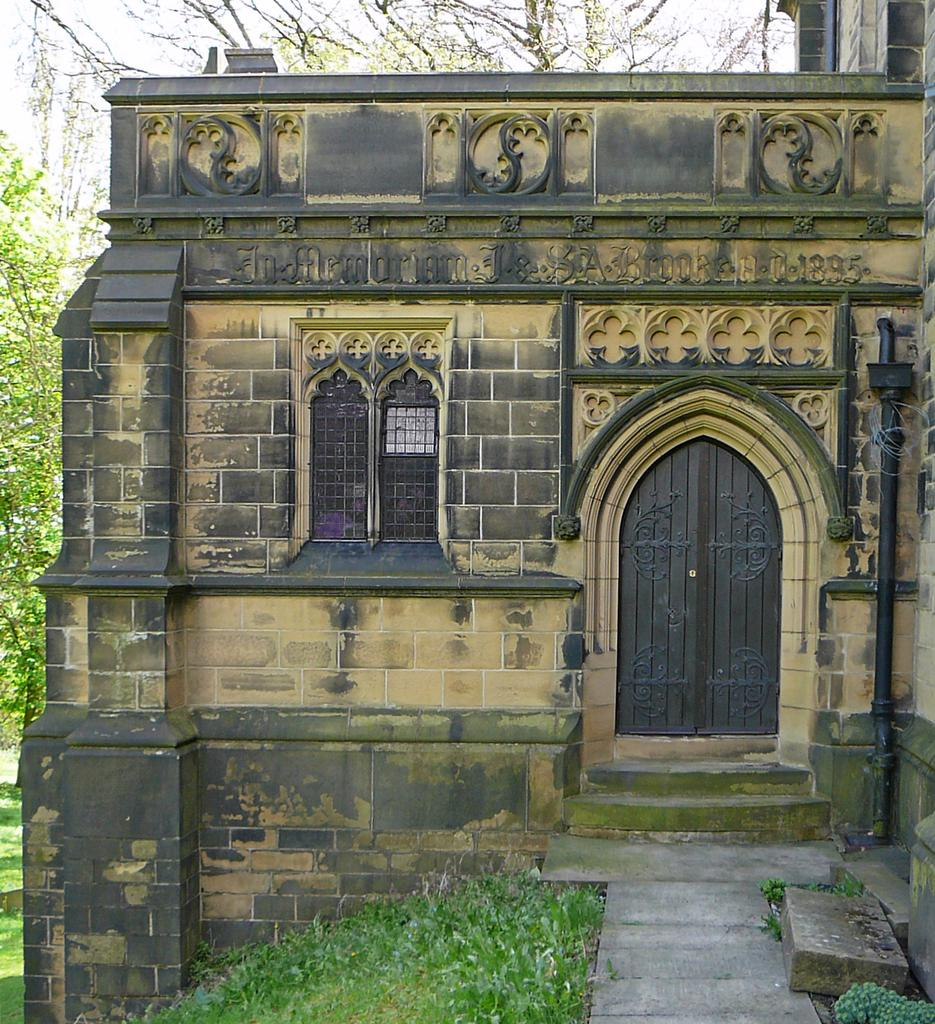What type of structure is present in the image? There is a building in the image. What type of vegetation can be seen in the image? There is grass visible in the image. What can be seen in the background of the image? There are trees and the sky visible in the background of the image. What type of fruit is being turned into a page in the image? There is no fruit or page present in the image. 